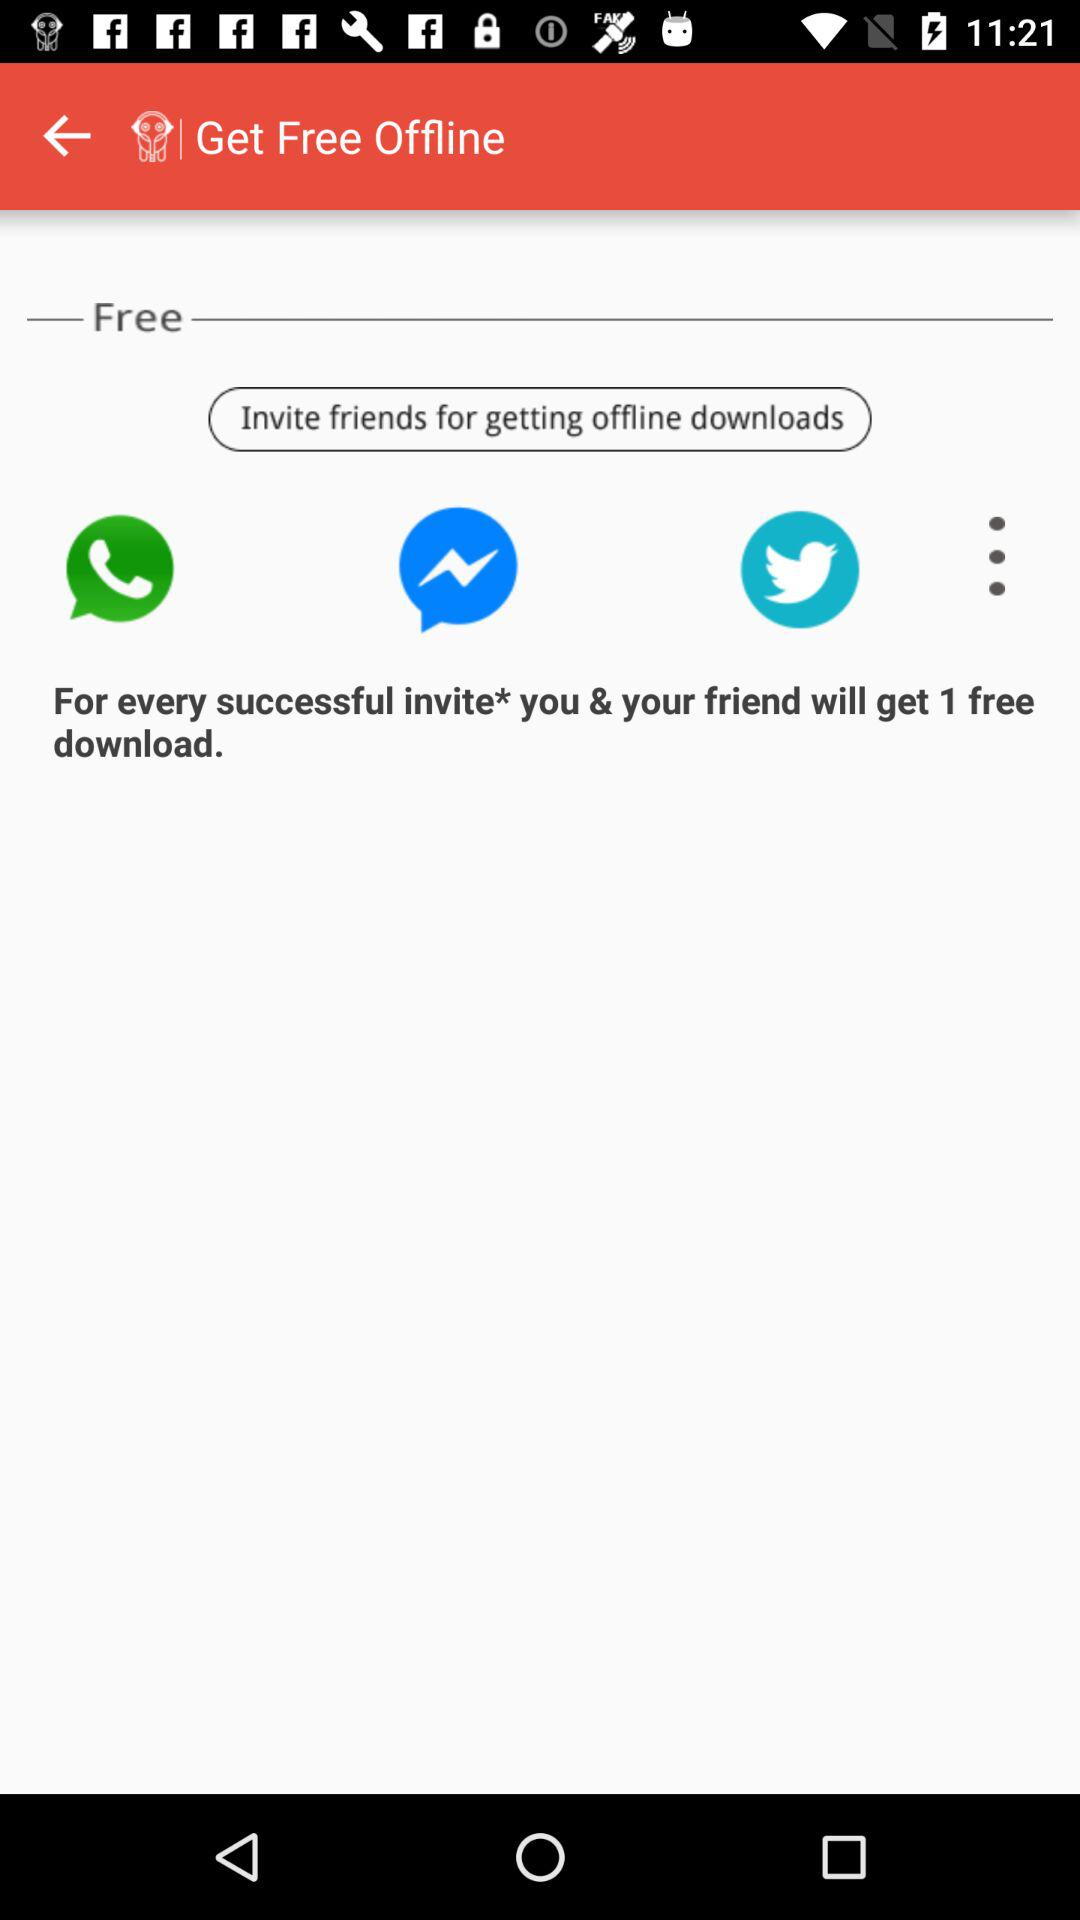How can we invite friends?
When the provided information is insufficient, respond with <no answer>. <no answer> 